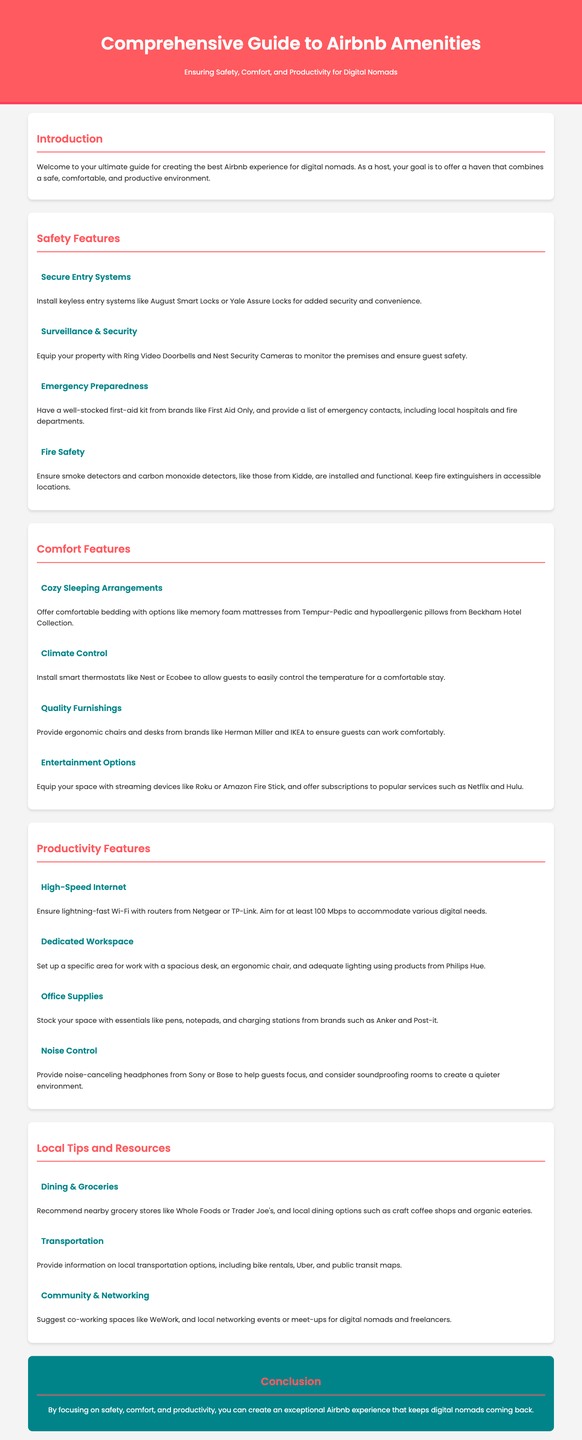what is the purpose of the guide? The guide aims to help hosts provide a safe, comfortable, and productive environment for digital nomads.
Answer: to help hosts provide a safe, comfortable, and productive environment for digital nomads what is one recommended type of entry system? The document suggests installing keyless entry systems like August Smart Locks or Yale Assure Locks.
Answer: keyless entry systems what is the target internet speed for guests? The guide recommends at least 100 Mbps to accommodate various digital needs.
Answer: 100 Mbps which brand is recommended for ergonomic chairs? The document mentions brands like Herman Miller for ergonomic chairs.
Answer: Herman Miller what feature helps with fire safety? Smoke detectors and carbon monoxide detectors are key features for fire safety.
Answer: Smoke detectors and carbon monoxide detectors what is one item you should provide for emergency preparedness? The guide suggests having a well-stocked first-aid kit.
Answer: first-aid kit how many sections focus on comfort features? There are four subsections under Comfort Features in the guide.
Answer: four which grocery stores are suggested in local tips? The document recommends grocery stores like Whole Foods or Trader Joe's.
Answer: Whole Foods or Trader Joe's what is included in the document's conclusion? The conclusion emphasizes creating an exceptional Airbnb experience through safety, comfort, and productivity.
Answer: creating an exceptional Airbnb experience through safety, comfort, and productivity 